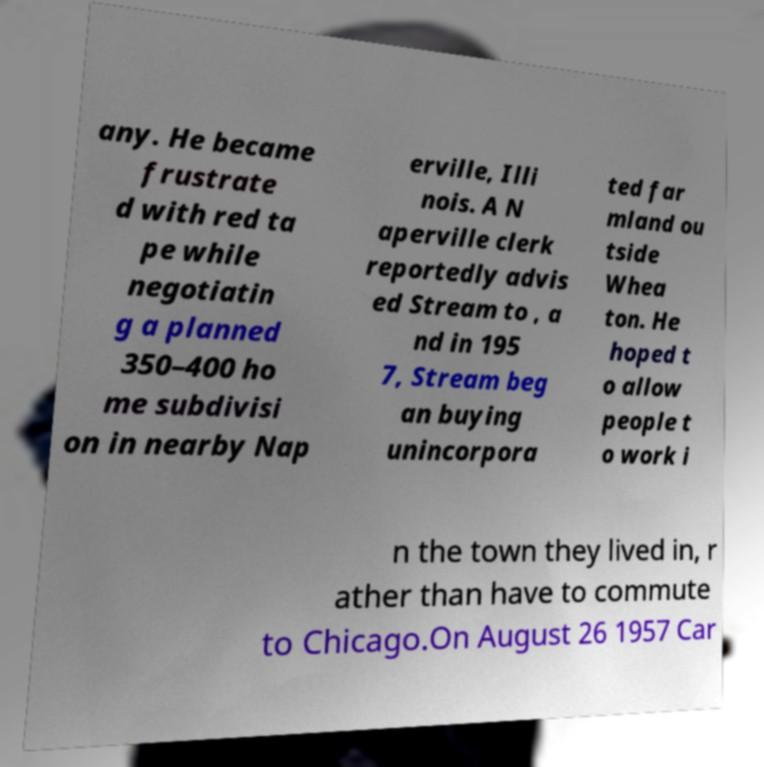I need the written content from this picture converted into text. Can you do that? any. He became frustrate d with red ta pe while negotiatin g a planned 350–400 ho me subdivisi on in nearby Nap erville, Illi nois. A N aperville clerk reportedly advis ed Stream to , a nd in 195 7, Stream beg an buying unincorpora ted far mland ou tside Whea ton. He hoped t o allow people t o work i n the town they lived in, r ather than have to commute to Chicago.On August 26 1957 Car 